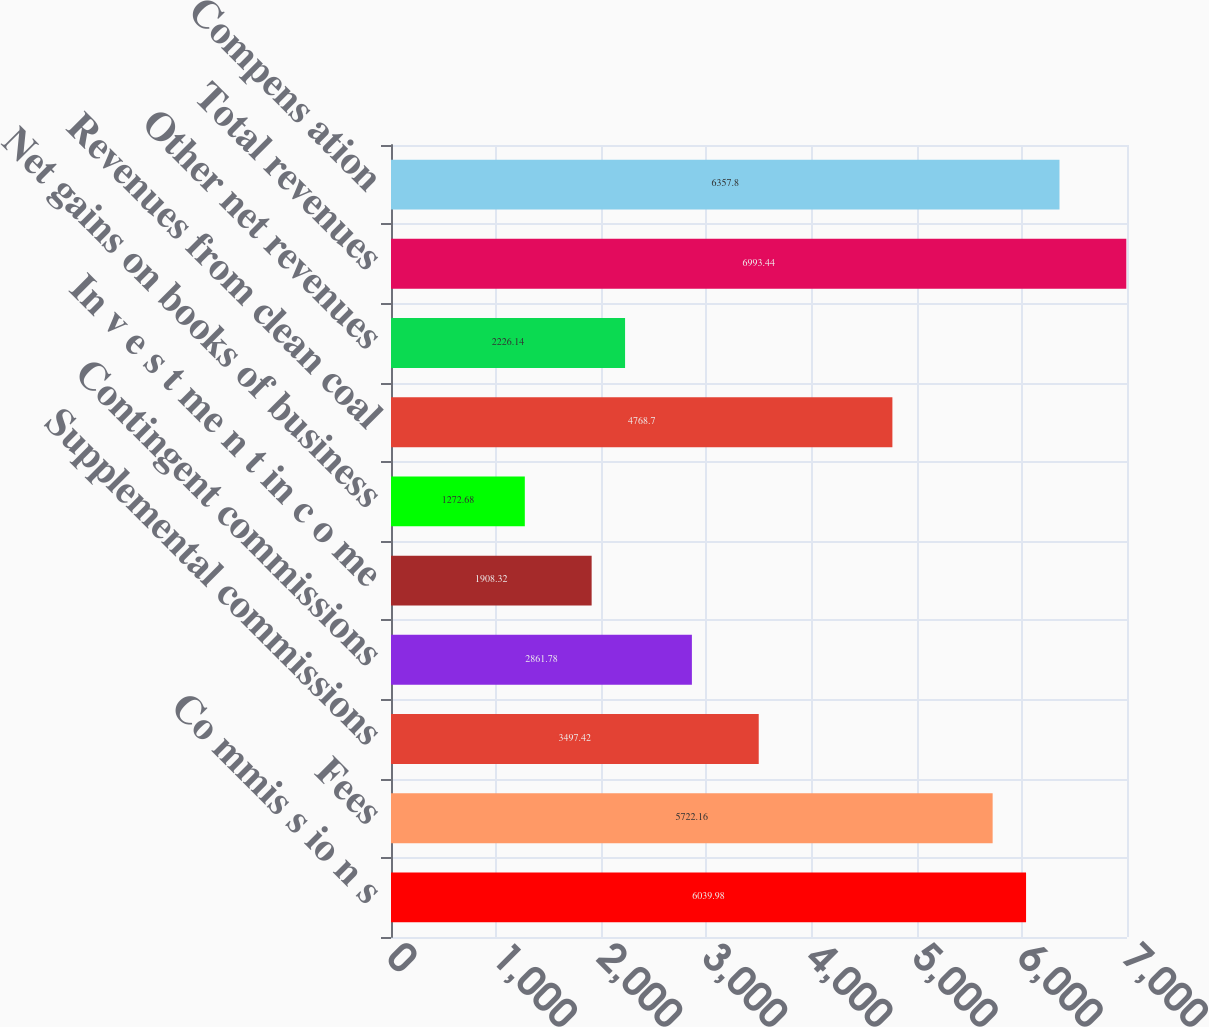<chart> <loc_0><loc_0><loc_500><loc_500><bar_chart><fcel>Co mmis s io n s<fcel>Fees<fcel>Supplemental commissions<fcel>Contingent commissions<fcel>In v e s t me n t in c o me<fcel>Net gains on books of business<fcel>Revenues from clean coal<fcel>Other net revenues<fcel>Total revenues<fcel>Compens ation<nl><fcel>6039.98<fcel>5722.16<fcel>3497.42<fcel>2861.78<fcel>1908.32<fcel>1272.68<fcel>4768.7<fcel>2226.14<fcel>6993.44<fcel>6357.8<nl></chart> 